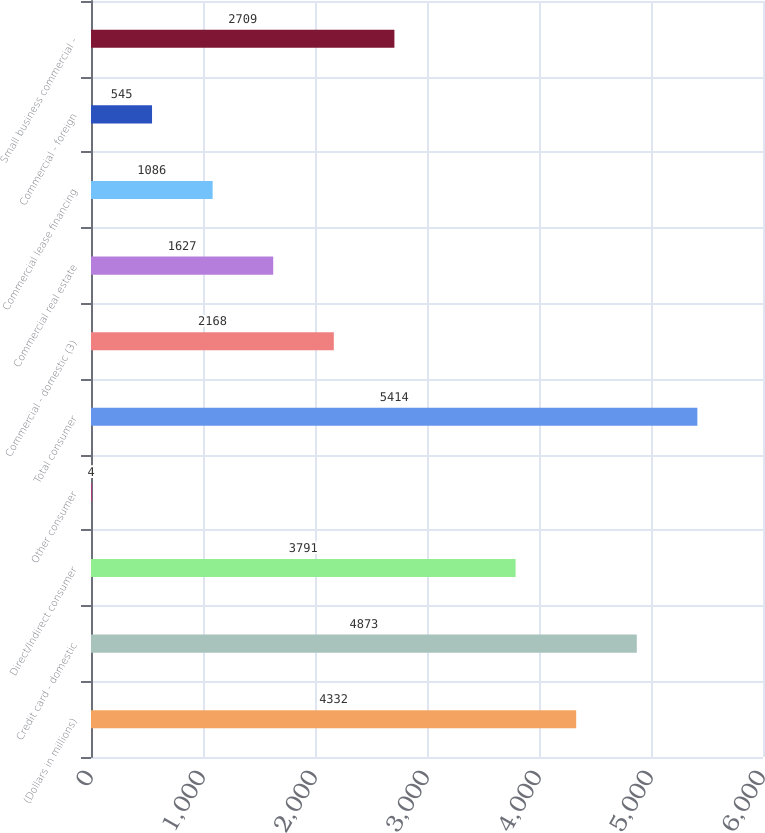Convert chart to OTSL. <chart><loc_0><loc_0><loc_500><loc_500><bar_chart><fcel>(Dollars in millions)<fcel>Credit card - domestic<fcel>Direct/Indirect consumer<fcel>Other consumer<fcel>Total consumer<fcel>Commercial - domestic (3)<fcel>Commercial real estate<fcel>Commercial lease financing<fcel>Commercial - foreign<fcel>Small business commercial -<nl><fcel>4332<fcel>4873<fcel>3791<fcel>4<fcel>5414<fcel>2168<fcel>1627<fcel>1086<fcel>545<fcel>2709<nl></chart> 